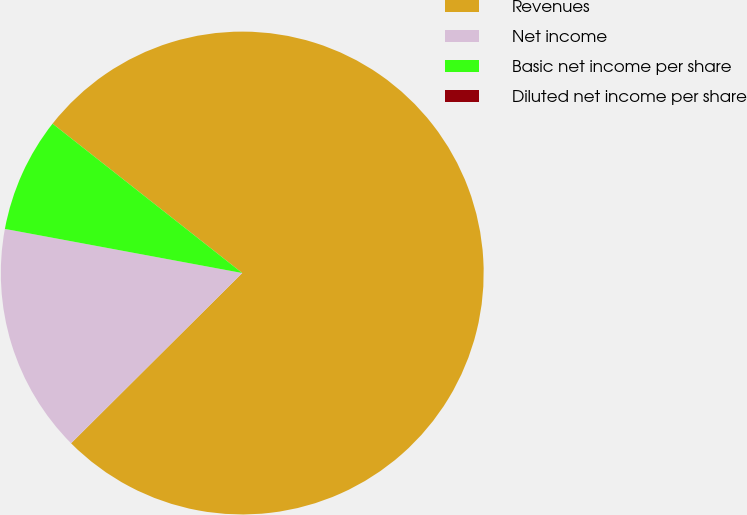Convert chart. <chart><loc_0><loc_0><loc_500><loc_500><pie_chart><fcel>Revenues<fcel>Net income<fcel>Basic net income per share<fcel>Diluted net income per share<nl><fcel>76.92%<fcel>15.38%<fcel>7.69%<fcel>0.0%<nl></chart> 